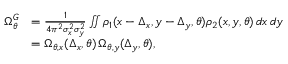Convert formula to latex. <formula><loc_0><loc_0><loc_500><loc_500>\begin{array} { r l } { \Omega _ { \theta } ^ { G } } & { = \frac { 1 } { 4 \pi ^ { 2 } \sigma _ { x } ^ { 2 } \sigma _ { y } ^ { 2 } } \iint \rho _ { 1 } ( x - \Delta _ { x } , y - \Delta _ { y } , \theta ) \rho _ { 2 } ( x , y , \theta ) \, d x \, d y } \\ & { = \Omega _ { \theta , x } ( \Delta _ { x } , \theta ) \, \Omega _ { \theta , y } ( \Delta _ { y } , \theta ) , } \end{array}</formula> 